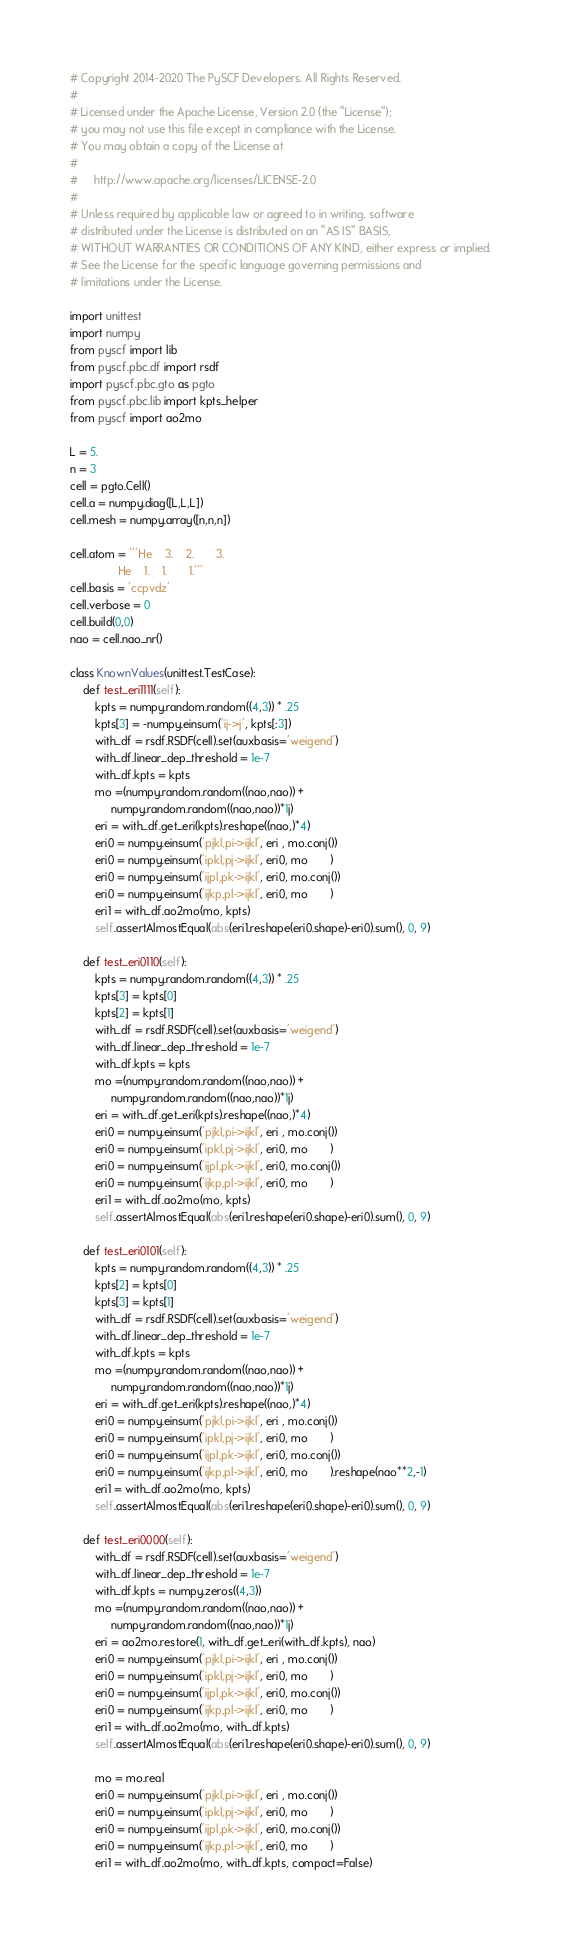Convert code to text. <code><loc_0><loc_0><loc_500><loc_500><_Python_># Copyright 2014-2020 The PySCF Developers. All Rights Reserved.
#
# Licensed under the Apache License, Version 2.0 (the "License");
# you may not use this file except in compliance with the License.
# You may obtain a copy of the License at
#
#     http://www.apache.org/licenses/LICENSE-2.0
#
# Unless required by applicable law or agreed to in writing, software
# distributed under the License is distributed on an "AS IS" BASIS,
# WITHOUT WARRANTIES OR CONDITIONS OF ANY KIND, either express or implied.
# See the License for the specific language governing permissions and
# limitations under the License.

import unittest
import numpy
from pyscf import lib
from pyscf.pbc.df import rsdf
import pyscf.pbc.gto as pgto
from pyscf.pbc.lib import kpts_helper
from pyscf import ao2mo

L = 5.
n = 3
cell = pgto.Cell()
cell.a = numpy.diag([L,L,L])
cell.mesh = numpy.array([n,n,n])

cell.atom = '''He    3.    2.       3.
               He    1.    1.       1.'''
cell.basis = 'ccpvdz'
cell.verbose = 0
cell.build(0,0)
nao = cell.nao_nr()

class KnownValues(unittest.TestCase):
    def test_eri1111(self):
        kpts = numpy.random.random((4,3)) * .25
        kpts[3] = -numpy.einsum('ij->j', kpts[:3])
        with_df = rsdf.RSDF(cell).set(auxbasis='weigend')
        with_df.linear_dep_threshold = 1e-7
        with_df.kpts = kpts
        mo =(numpy.random.random((nao,nao)) +
             numpy.random.random((nao,nao))*1j)
        eri = with_df.get_eri(kpts).reshape((nao,)*4)
        eri0 = numpy.einsum('pjkl,pi->ijkl', eri , mo.conj())
        eri0 = numpy.einsum('ipkl,pj->ijkl', eri0, mo       )
        eri0 = numpy.einsum('ijpl,pk->ijkl', eri0, mo.conj())
        eri0 = numpy.einsum('ijkp,pl->ijkl', eri0, mo       )
        eri1 = with_df.ao2mo(mo, kpts)
        self.assertAlmostEqual(abs(eri1.reshape(eri0.shape)-eri0).sum(), 0, 9)

    def test_eri0110(self):
        kpts = numpy.random.random((4,3)) * .25
        kpts[3] = kpts[0]
        kpts[2] = kpts[1]
        with_df = rsdf.RSDF(cell).set(auxbasis='weigend')
        with_df.linear_dep_threshold = 1e-7
        with_df.kpts = kpts
        mo =(numpy.random.random((nao,nao)) +
             numpy.random.random((nao,nao))*1j)
        eri = with_df.get_eri(kpts).reshape((nao,)*4)
        eri0 = numpy.einsum('pjkl,pi->ijkl', eri , mo.conj())
        eri0 = numpy.einsum('ipkl,pj->ijkl', eri0, mo       )
        eri0 = numpy.einsum('ijpl,pk->ijkl', eri0, mo.conj())
        eri0 = numpy.einsum('ijkp,pl->ijkl', eri0, mo       )
        eri1 = with_df.ao2mo(mo, kpts)
        self.assertAlmostEqual(abs(eri1.reshape(eri0.shape)-eri0).sum(), 0, 9)

    def test_eri0101(self):
        kpts = numpy.random.random((4,3)) * .25
        kpts[2] = kpts[0]
        kpts[3] = kpts[1]
        with_df = rsdf.RSDF(cell).set(auxbasis='weigend')
        with_df.linear_dep_threshold = 1e-7
        with_df.kpts = kpts
        mo =(numpy.random.random((nao,nao)) +
             numpy.random.random((nao,nao))*1j)
        eri = with_df.get_eri(kpts).reshape((nao,)*4)
        eri0 = numpy.einsum('pjkl,pi->ijkl', eri , mo.conj())
        eri0 = numpy.einsum('ipkl,pj->ijkl', eri0, mo       )
        eri0 = numpy.einsum('ijpl,pk->ijkl', eri0, mo.conj())
        eri0 = numpy.einsum('ijkp,pl->ijkl', eri0, mo       ).reshape(nao**2,-1)
        eri1 = with_df.ao2mo(mo, kpts)
        self.assertAlmostEqual(abs(eri1.reshape(eri0.shape)-eri0).sum(), 0, 9)

    def test_eri0000(self):
        with_df = rsdf.RSDF(cell).set(auxbasis='weigend')
        with_df.linear_dep_threshold = 1e-7
        with_df.kpts = numpy.zeros((4,3))
        mo =(numpy.random.random((nao,nao)) +
             numpy.random.random((nao,nao))*1j)
        eri = ao2mo.restore(1, with_df.get_eri(with_df.kpts), nao)
        eri0 = numpy.einsum('pjkl,pi->ijkl', eri , mo.conj())
        eri0 = numpy.einsum('ipkl,pj->ijkl', eri0, mo       )
        eri0 = numpy.einsum('ijpl,pk->ijkl', eri0, mo.conj())
        eri0 = numpy.einsum('ijkp,pl->ijkl', eri0, mo       )
        eri1 = with_df.ao2mo(mo, with_df.kpts)
        self.assertAlmostEqual(abs(eri1.reshape(eri0.shape)-eri0).sum(), 0, 9)

        mo = mo.real
        eri0 = numpy.einsum('pjkl,pi->ijkl', eri , mo.conj())
        eri0 = numpy.einsum('ipkl,pj->ijkl', eri0, mo       )
        eri0 = numpy.einsum('ijpl,pk->ijkl', eri0, mo.conj())
        eri0 = numpy.einsum('ijkp,pl->ijkl', eri0, mo       )
        eri1 = with_df.ao2mo(mo, with_df.kpts, compact=False)</code> 